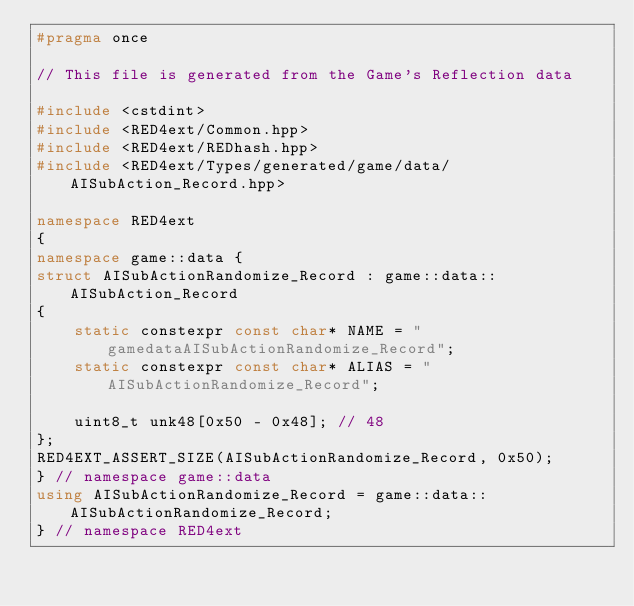<code> <loc_0><loc_0><loc_500><loc_500><_C++_>#pragma once

// This file is generated from the Game's Reflection data

#include <cstdint>
#include <RED4ext/Common.hpp>
#include <RED4ext/REDhash.hpp>
#include <RED4ext/Types/generated/game/data/AISubAction_Record.hpp>

namespace RED4ext
{
namespace game::data { 
struct AISubActionRandomize_Record : game::data::AISubAction_Record
{
    static constexpr const char* NAME = "gamedataAISubActionRandomize_Record";
    static constexpr const char* ALIAS = "AISubActionRandomize_Record";

    uint8_t unk48[0x50 - 0x48]; // 48
};
RED4EXT_ASSERT_SIZE(AISubActionRandomize_Record, 0x50);
} // namespace game::data
using AISubActionRandomize_Record = game::data::AISubActionRandomize_Record;
} // namespace RED4ext
</code> 